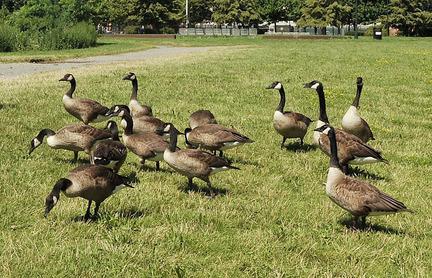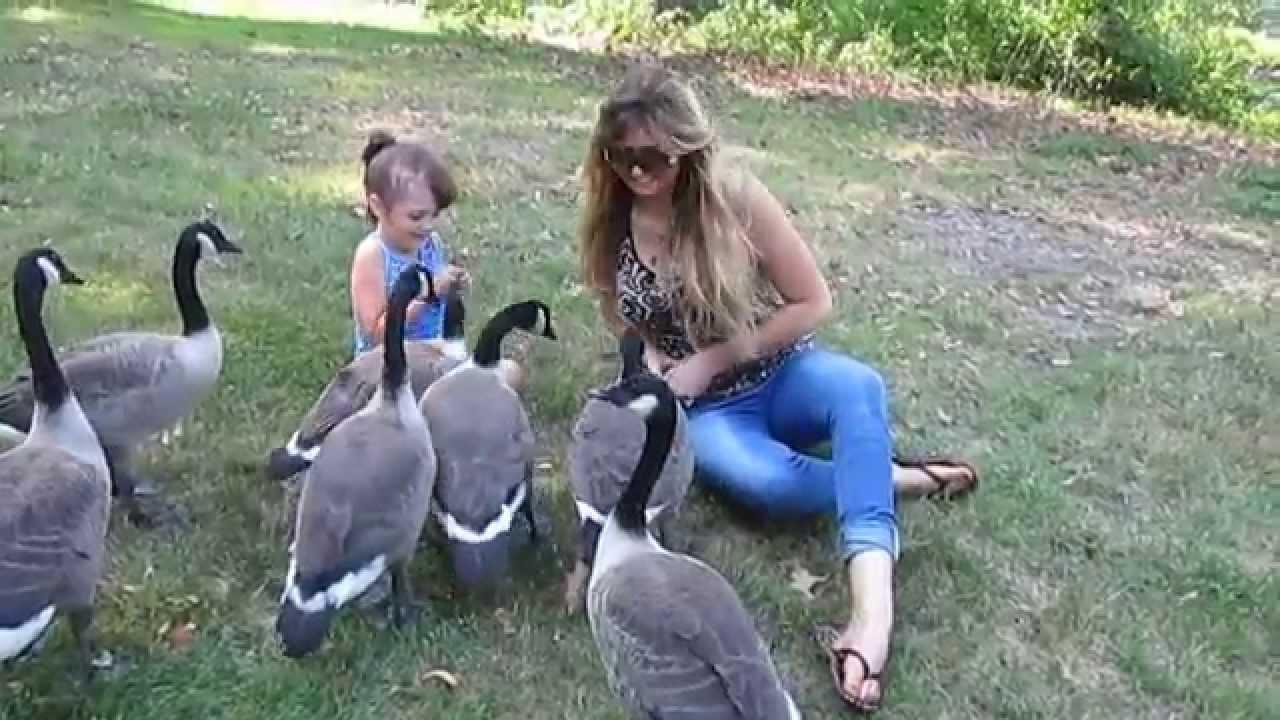The first image is the image on the left, the second image is the image on the right. Considering the images on both sides, is "A girl with long blonde hair is seated beside birds in one of the images." valid? Answer yes or no. Yes. The first image is the image on the left, the second image is the image on the right. Examine the images to the left and right. Is the description "The left image has at least 4 birds facing left." accurate? Answer yes or no. Yes. 